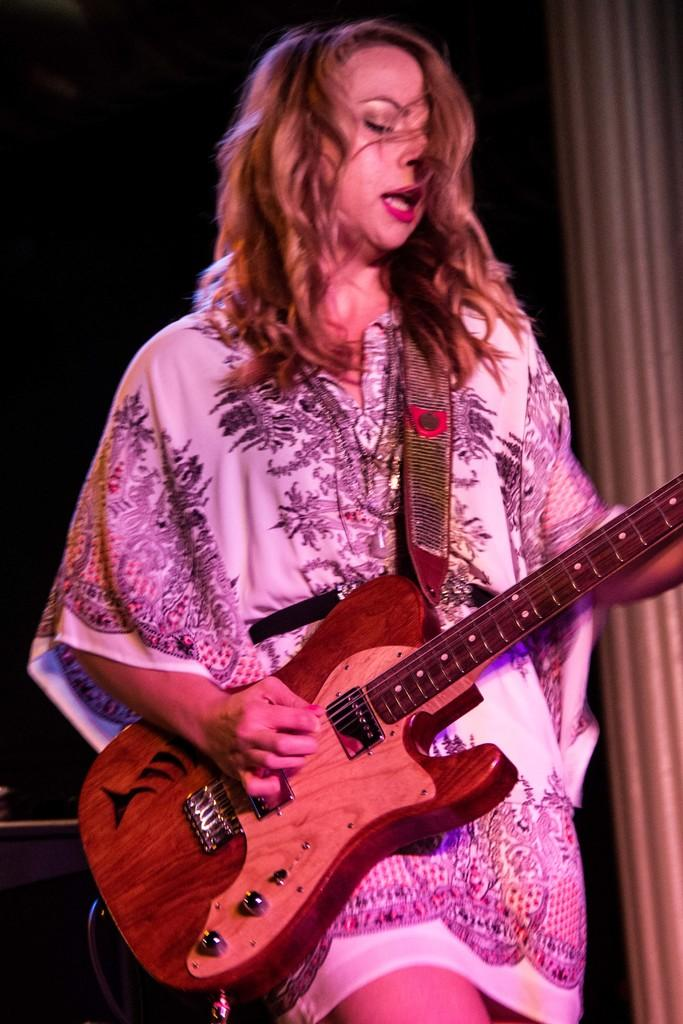Who is the main subject in the image? There is a lady in the image. What is the lady holding in the image? The lady is holding a guitar. What is the lady doing with the guitar? The lady is playing the guitar. How would you describe the background of the image? The background of the image is dark. Are there any fairies visible in the image? No, there are no fairies present in the image. What type of food is the lady eating while playing the guitar? The image does not show the lady eating any food while playing the guitar. 